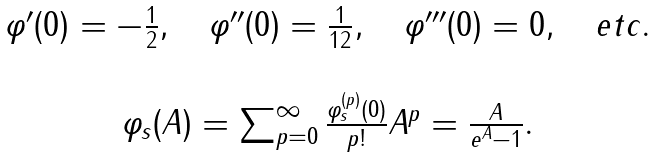<formula> <loc_0><loc_0><loc_500><loc_500>\begin{array} { c } \varphi ^ { \prime } ( 0 ) = - \frac { 1 } { 2 } , \quad \varphi ^ { \prime \prime } ( 0 ) = \frac { 1 } { 1 2 } , \quad \varphi ^ { \prime \prime \prime } ( 0 ) = 0 , \quad e t c . \\ \\ \varphi _ { s } ( A ) = \sum _ { p = 0 } ^ { \infty } \frac { \varphi _ { s } ^ { ( p ) } ( 0 ) } { p ! } A ^ { p } = \frac { A } { e ^ { A } - 1 } . \end{array}</formula> 